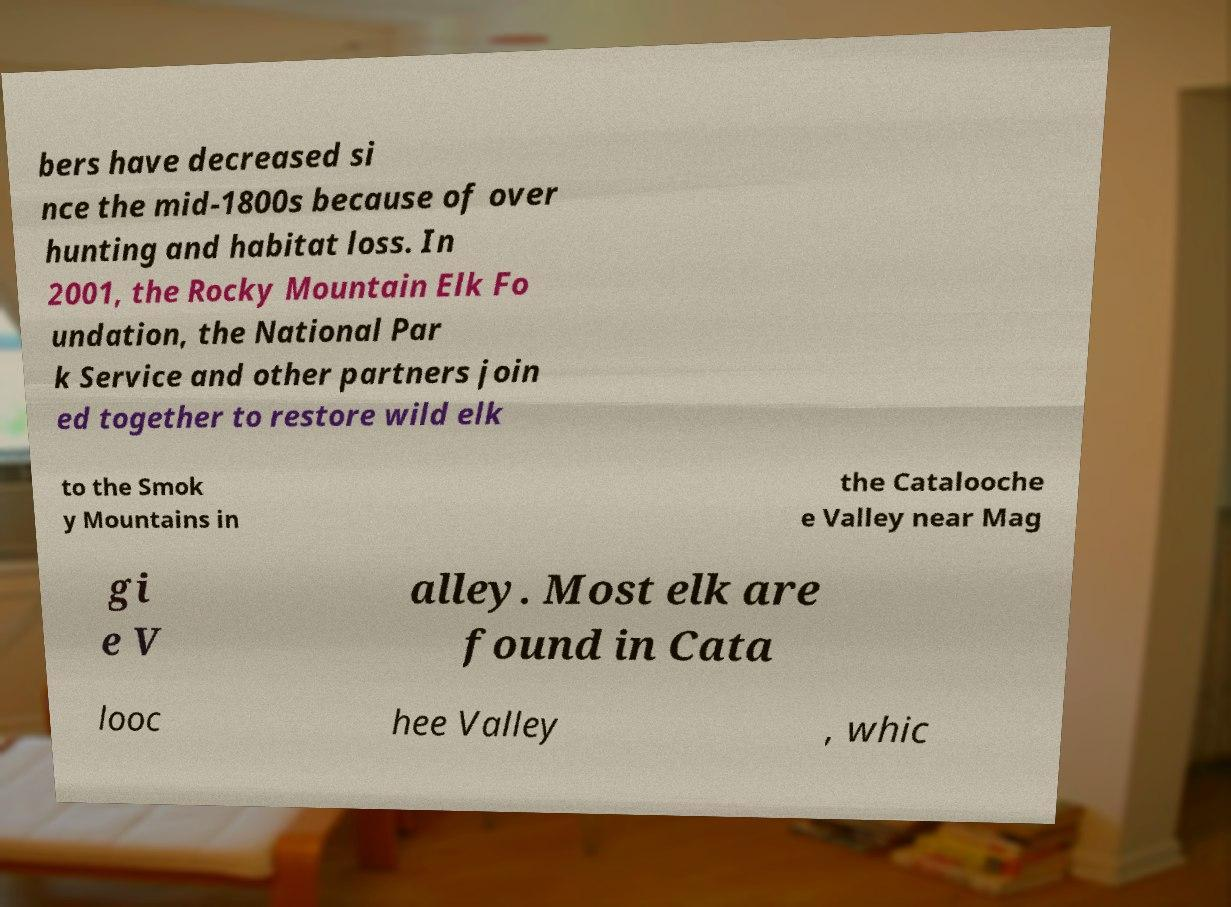There's text embedded in this image that I need extracted. Can you transcribe it verbatim? bers have decreased si nce the mid-1800s because of over hunting and habitat loss. In 2001, the Rocky Mountain Elk Fo undation, the National Par k Service and other partners join ed together to restore wild elk to the Smok y Mountains in the Catalooche e Valley near Mag gi e V alley. Most elk are found in Cata looc hee Valley , whic 